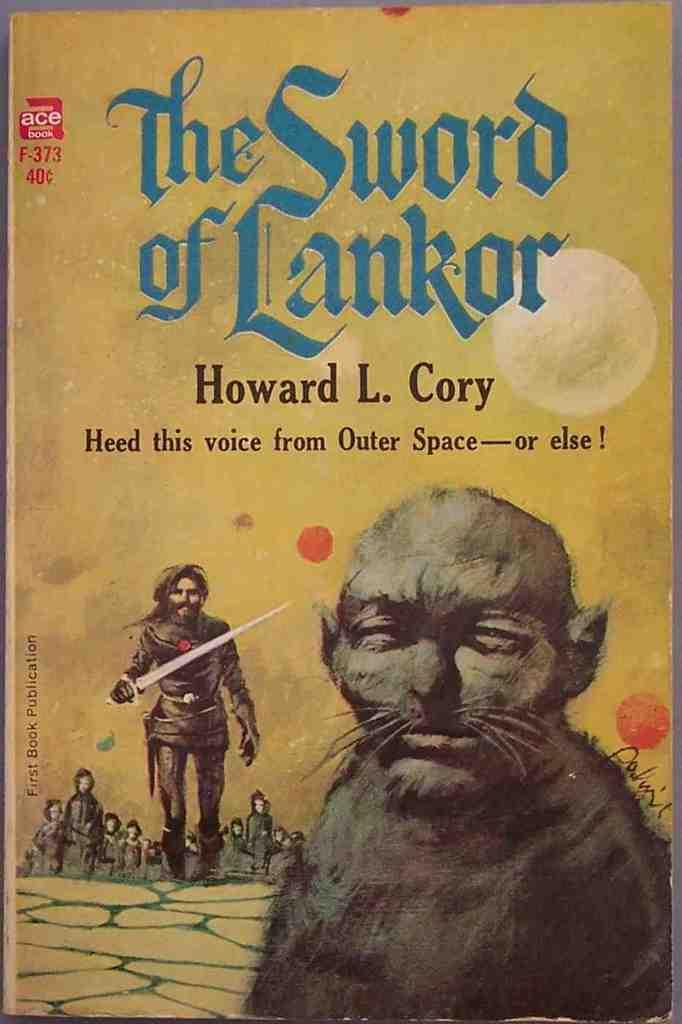<image>
Create a compact narrative representing the image presented. The book "The Sword of Lankor" by Howard L. Cory. 